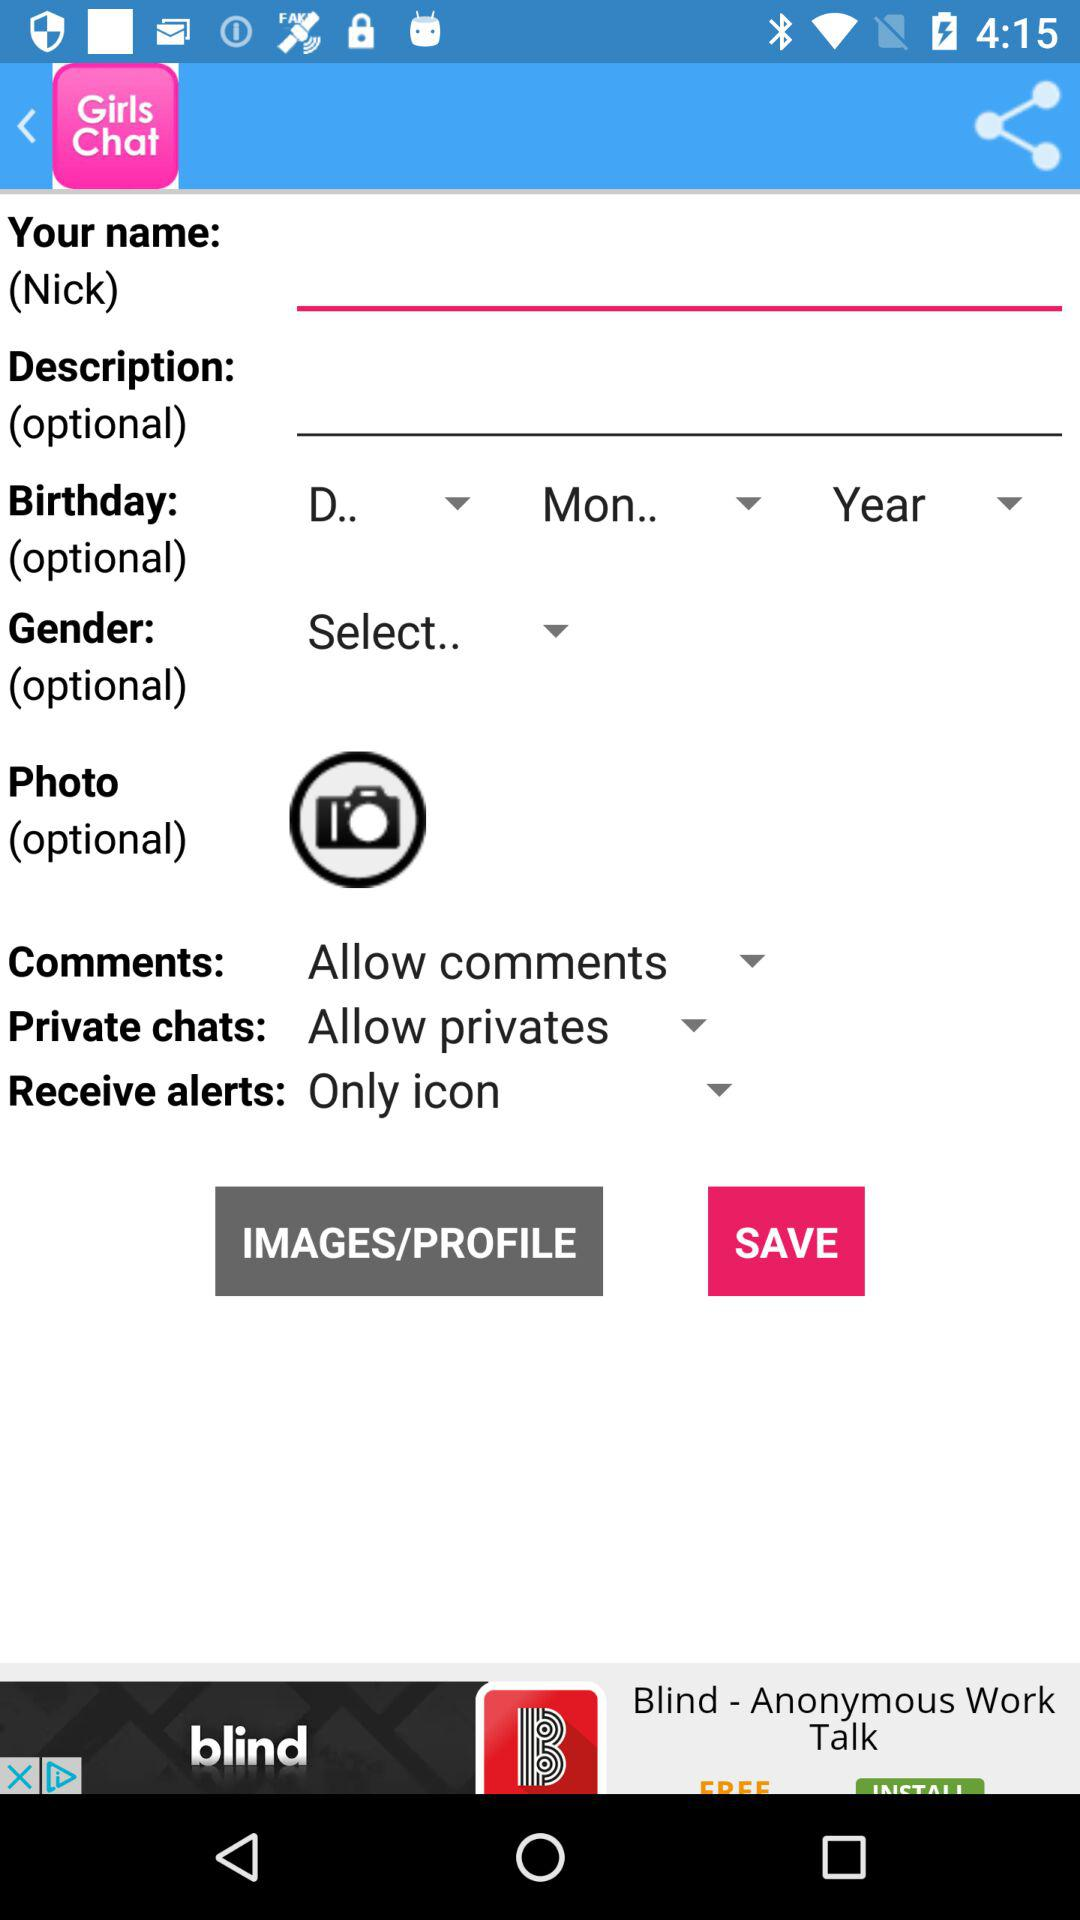What's the setting for "Comments"? The setting for "Comments" is "Allow comments". 